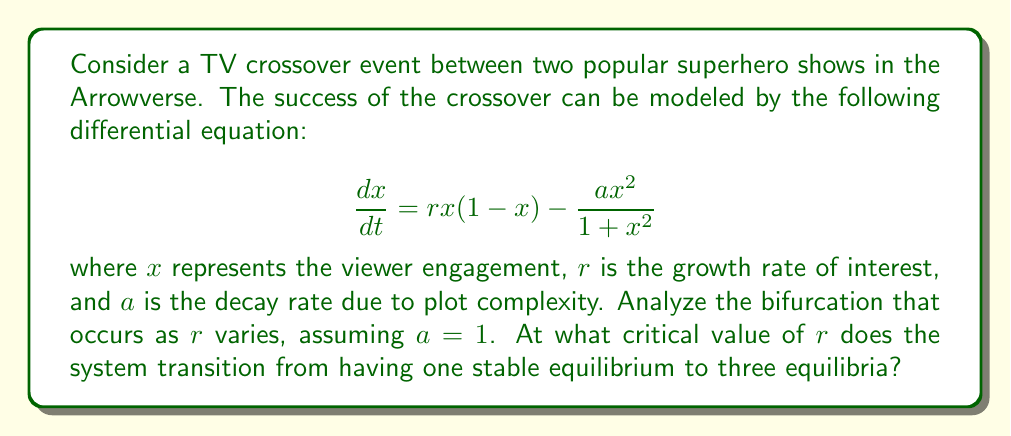Give your solution to this math problem. To analyze the bifurcation, we need to follow these steps:

1) Find the equilibria by setting $\frac{dx}{dt} = 0$:

   $$rx(1-x) - \frac{x^2}{1+x^2} = 0$$

2) This can be rearranged to:

   $$rx(1-x)(1+x^2) = x^2$$

   $$rx + rx^3 - rx^2 - rx^4 = x^2$$

   $$rx + rx^3 - x^2 - rx^4 = 0$$

3) For a bifurcation to occur, this equation must have a double root. This happens when the equation and its derivative are simultaneously zero.

4) The derivative with respect to $x$ is:

   $$r + 3rx^2 - 2x - 4rx^3 = 0$$

5) At the bifurcation point, $x$ satisfies both equations. Dividing the original equation by $x$ (assuming $x \neq 0$):

   $$r + rx^2 - x - rx^3 = 0$$

6) Subtracting this from the derivative equation:

   $$2rx^2 - x - 3rx^3 = 0$$

   $$x(2rx - 1 - 3rx^2) = 0$$

7) The non-zero solution satisfies:

   $$2rx - 1 - 3rx^2 = 0$$

   $$3rx^2 - 2rx + 1 = 0$$

8) This is a quadratic in $x$. For a double root, its discriminant must be zero:

   $$(2r)^2 - 4(3r)(1) = 0$$

   $$4r^2 - 12r = 0$$

   $$4r(r - 3) = 0$$

9) The non-zero solution is $r = 3$.

Therefore, the critical value of $r$ at which the bifurcation occurs is 3.
Answer: $r = 3$ 